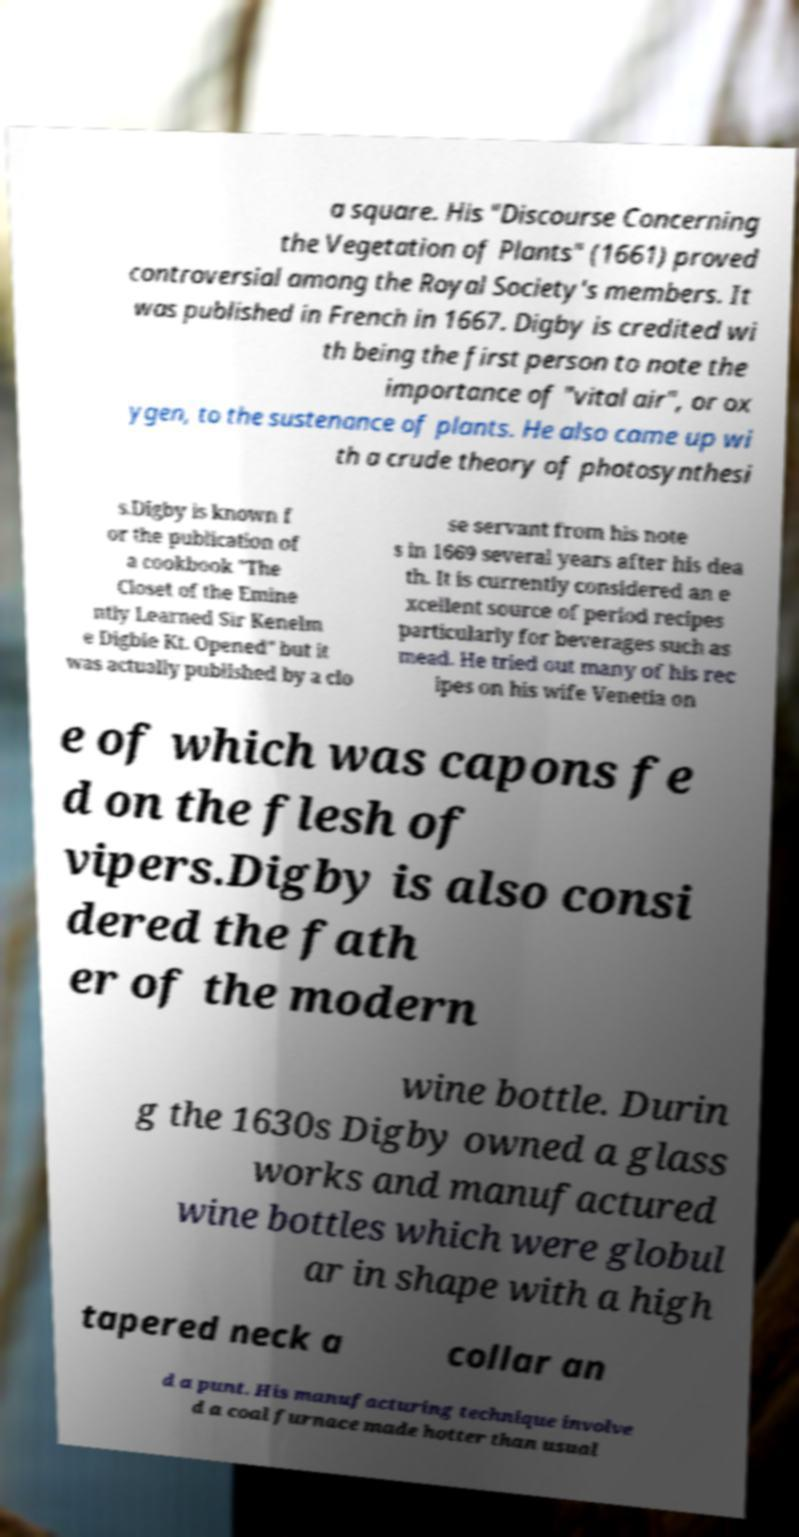Could you extract and type out the text from this image? a square. His "Discourse Concerning the Vegetation of Plants" (1661) proved controversial among the Royal Society's members. It was published in French in 1667. Digby is credited wi th being the first person to note the importance of "vital air", or ox ygen, to the sustenance of plants. He also came up wi th a crude theory of photosynthesi s.Digby is known f or the publication of a cookbook "The Closet of the Emine ntly Learned Sir Kenelm e Digbie Kt. Opened" but it was actually published by a clo se servant from his note s in 1669 several years after his dea th. It is currently considered an e xcellent source of period recipes particularly for beverages such as mead. He tried out many of his rec ipes on his wife Venetia on e of which was capons fe d on the flesh of vipers.Digby is also consi dered the fath er of the modern wine bottle. Durin g the 1630s Digby owned a glass works and manufactured wine bottles which were globul ar in shape with a high tapered neck a collar an d a punt. His manufacturing technique involve d a coal furnace made hotter than usual 